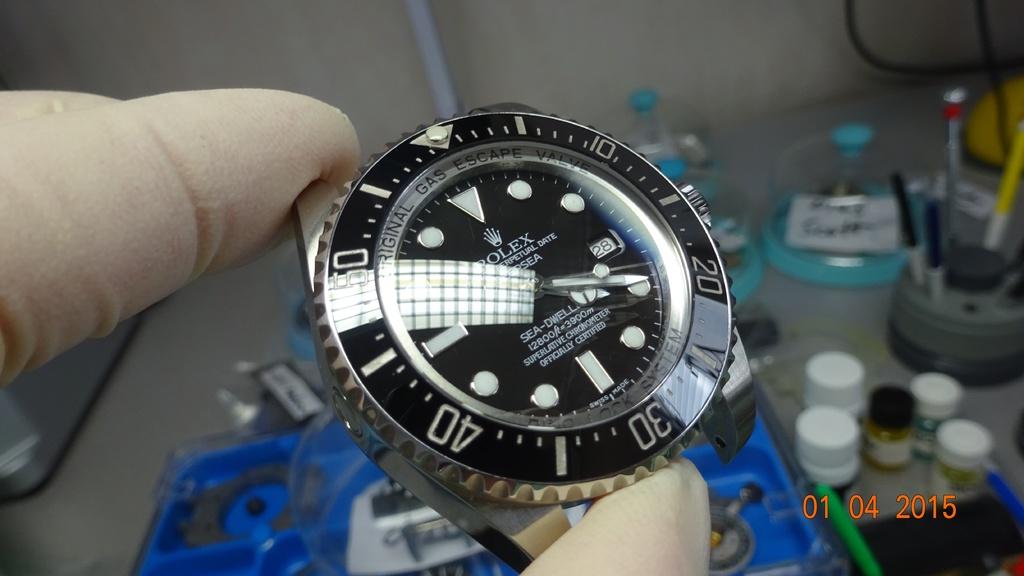What brand is visible on the watch face?
Provide a short and direct response. Rolex. 